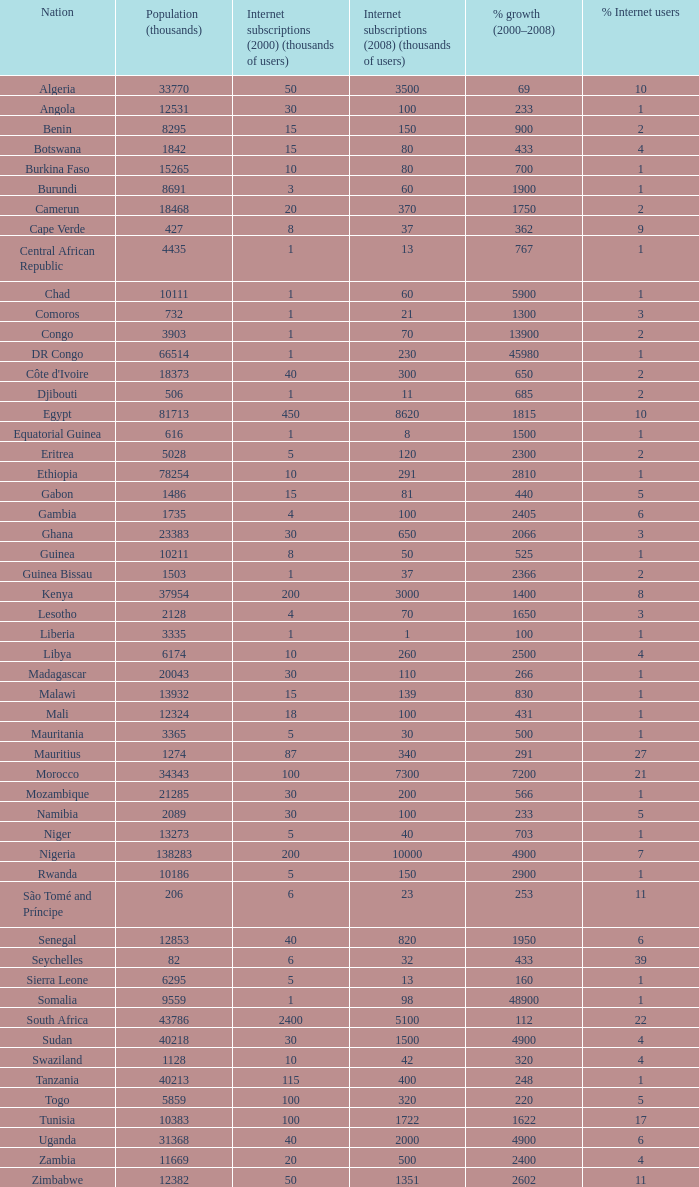What is the proportion of growth in ethiopia from 2000-2008? 2810.0. 